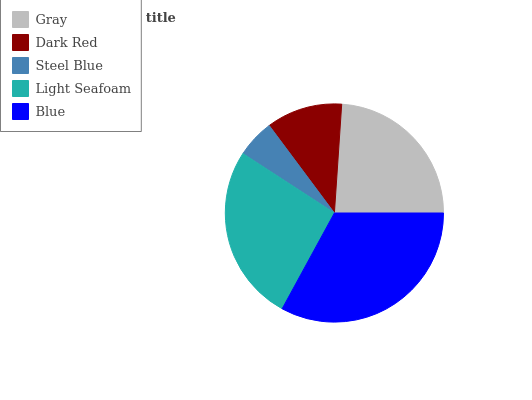Is Steel Blue the minimum?
Answer yes or no. Yes. Is Blue the maximum?
Answer yes or no. Yes. Is Dark Red the minimum?
Answer yes or no. No. Is Dark Red the maximum?
Answer yes or no. No. Is Gray greater than Dark Red?
Answer yes or no. Yes. Is Dark Red less than Gray?
Answer yes or no. Yes. Is Dark Red greater than Gray?
Answer yes or no. No. Is Gray less than Dark Red?
Answer yes or no. No. Is Gray the high median?
Answer yes or no. Yes. Is Gray the low median?
Answer yes or no. Yes. Is Dark Red the high median?
Answer yes or no. No. Is Steel Blue the low median?
Answer yes or no. No. 